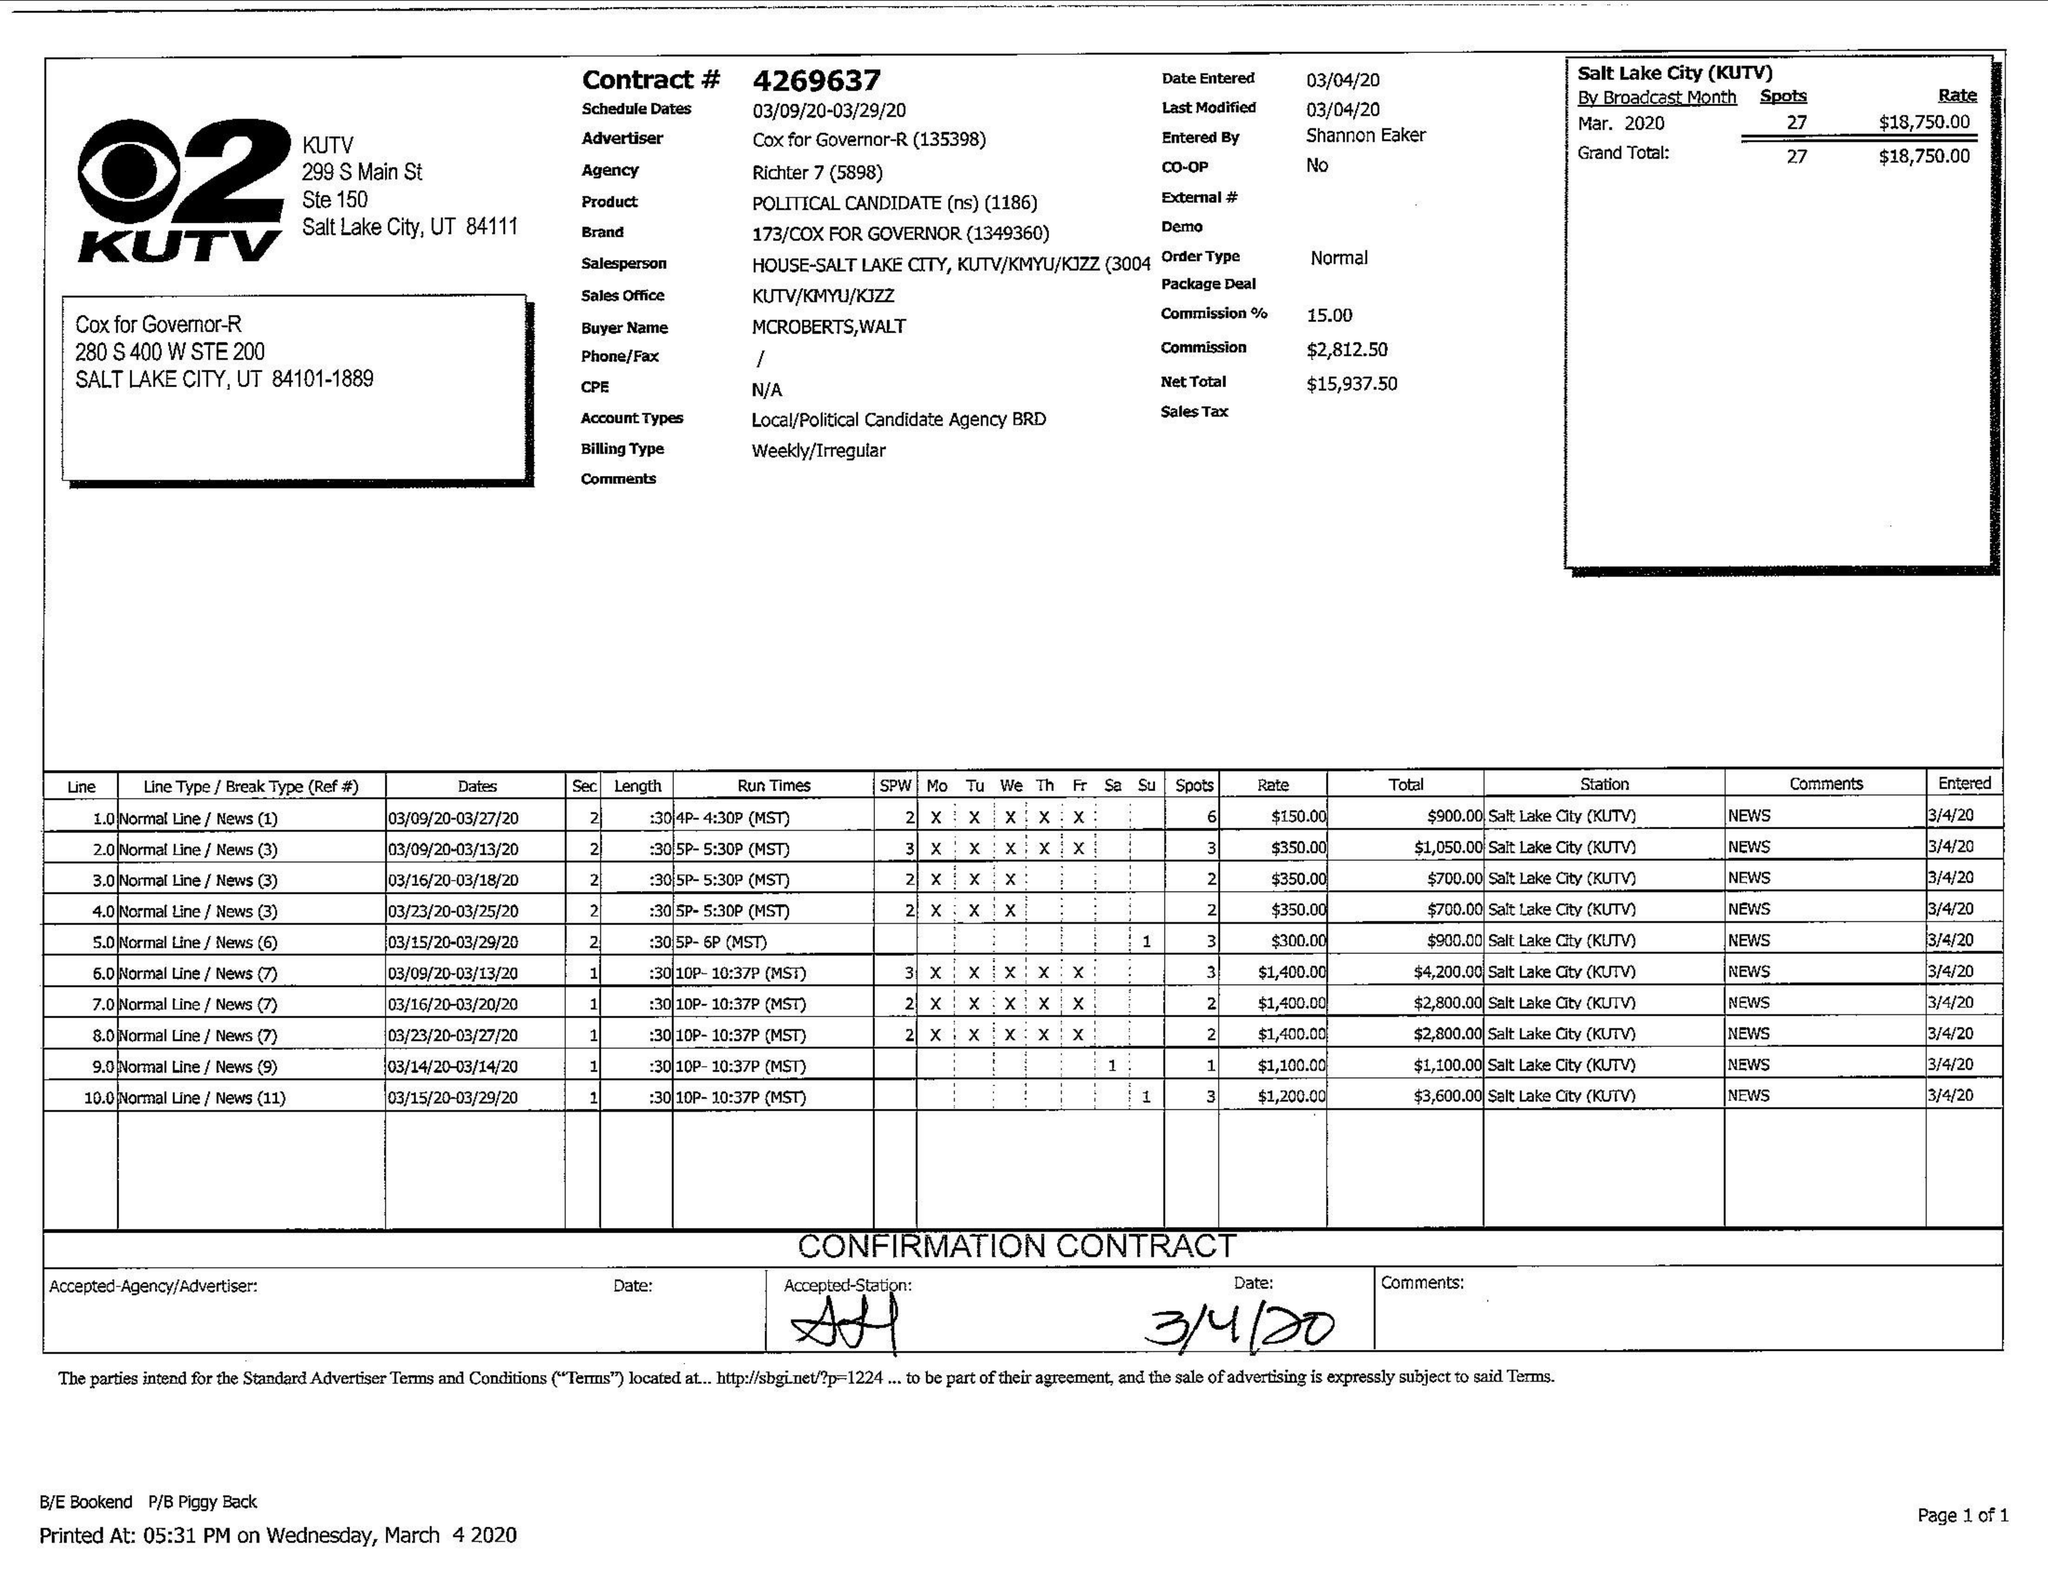What is the value for the advertiser?
Answer the question using a single word or phrase. COX FOR GOVERNOR-R 